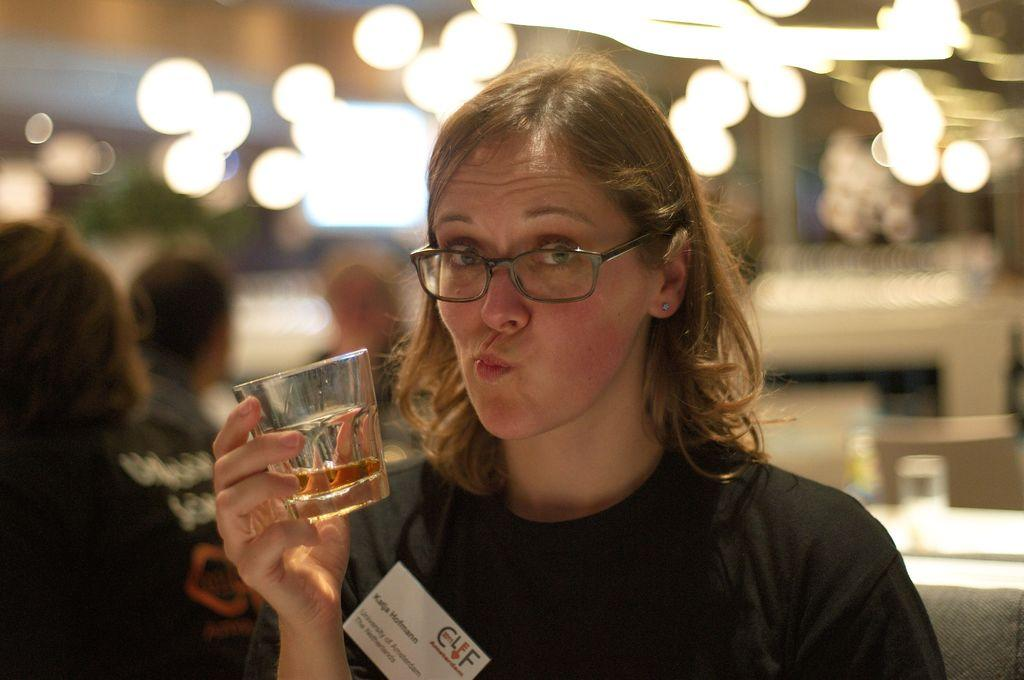How many people are present in the image? There are four persons in the image. What is one person holding in the image? One person is holding a glass with a drink. What can be seen in the background of the image? There are lights visible in the background of the image. What type of stew is being prepared by the persons in the image? There is no indication in the image that any stew is being prepared or served. What kind of art can be seen hanging on the wall in the image? There is no art visible on the wall in the image. 